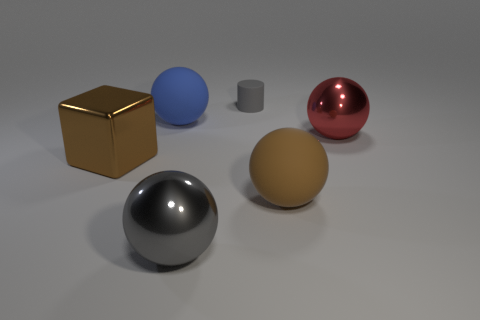Add 4 big gray shiny cubes. How many objects exist? 10 Subtract all blocks. How many objects are left? 5 Add 3 gray objects. How many gray objects are left? 5 Add 6 blue spheres. How many blue spheres exist? 7 Subtract 0 purple cubes. How many objects are left? 6 Subtract all brown cubes. Subtract all large cylinders. How many objects are left? 5 